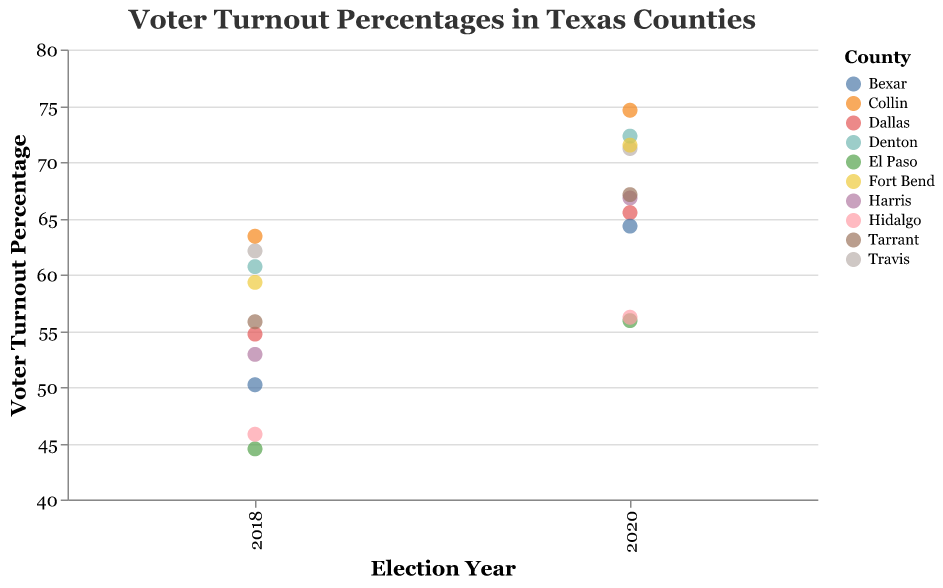What is the title of the plot? The title is displayed at the top of the plot and reads, "Voter Turnout Percentages in Texas Counties".
Answer: Voter Turnout Percentages in Texas Counties What is the voter turnout percentage for Harris County in 2020? The point representing Harris County in the 2020 column has a tooltip showing "66.8".
Answer: 66.8% Which county had the highest voter turnout percentage in the 2020 election? By observing the highest point in the 2020 column, Collin County has the highest voter turnout at 74.6%.
Answer: Collin County How did voter turnout in El Paso County change from 2018 to 2020? El Paso's voter turnout was 44.5% in 2018 and increased to 55.9% in 2020. The increase is calculated as 55.9 - 44.5 = 11.4%.
Answer: Increased by 11.4% Compare the voter turnout percentage of Travis County between 2018 and 2020. Travis County had a voter turnout percentage of 62.1% in 2018 and 71.2% in 2020, so the increase is 71.2 - 62.1 = 9.1%.
Answer: Increased by 9.1% Which county had the lowest voter turnout percentage in 2018? By identifying the lowest point in the 2018 column, El Paso County has the lowest voter turnout at 44.5%.
Answer: El Paso County What is the average voter turnout percentage for Bexar County across the two election years? Bexar County’s voter turnout was 50.2% in 2018 and 64.3% in 2020. The average is calculated as (50.2 + 64.3) / 2 = 57.25%.
Answer: 57.25% How many counties had a voter turnout percentage below 60% in 2020? By counting the points below the 60% mark in the 2020 column, there are 3 counties: Dallas, El Paso, and Hidalgo.
Answer: 3 counties Which county had a greater improvement in voter turnout between 2018 and 2020, Fort Bend or Denton? Fort Bend improved from 59.3% to 71.5%, a difference of 12.2%. Denton improved from 60.7% to 72.3%, a difference of 11.6%. Comparing the differences, Fort Bend had a greater improvement.
Answer: Fort Bend Among the counties listed, which one showed the largest increase in voter turnout percentages from 2018 to 2020? By calculating the differences for each county, Collin County showed the largest increase (74.6% - 63.4% = 11.2%). However, checking all counties, Travis County shows a larger increase (71.2% - 62.1% = 9.1%).
Answer: Travis County 